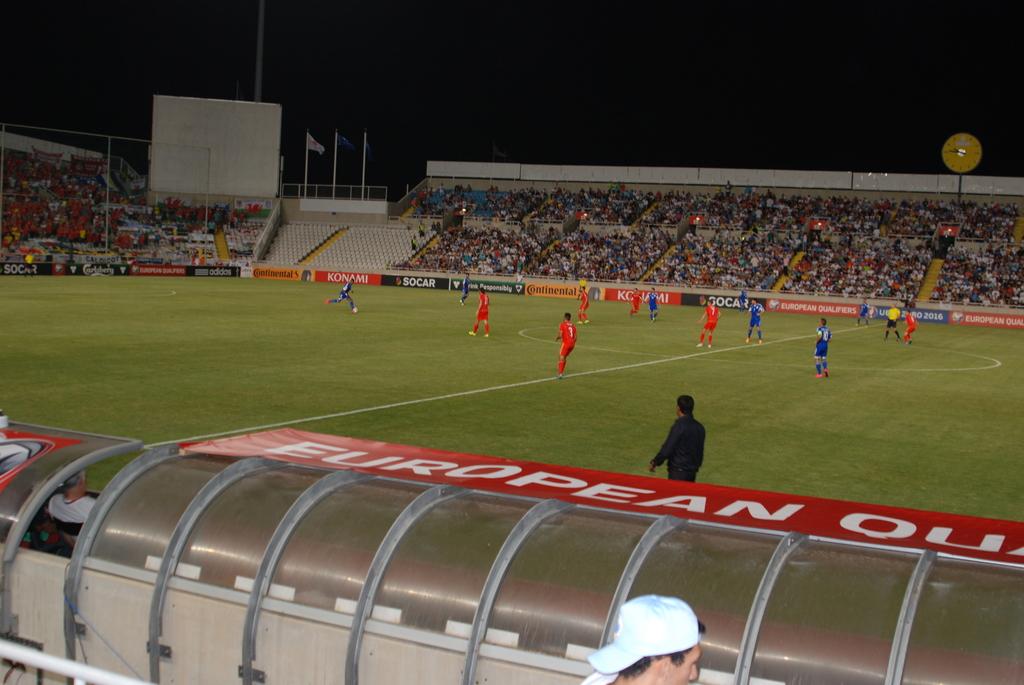Which continent is featured on the red banner at the bottom?
Your answer should be very brief. Europe. Who is one of the sponsors seen in the background?
Your answer should be very brief. Socar. 